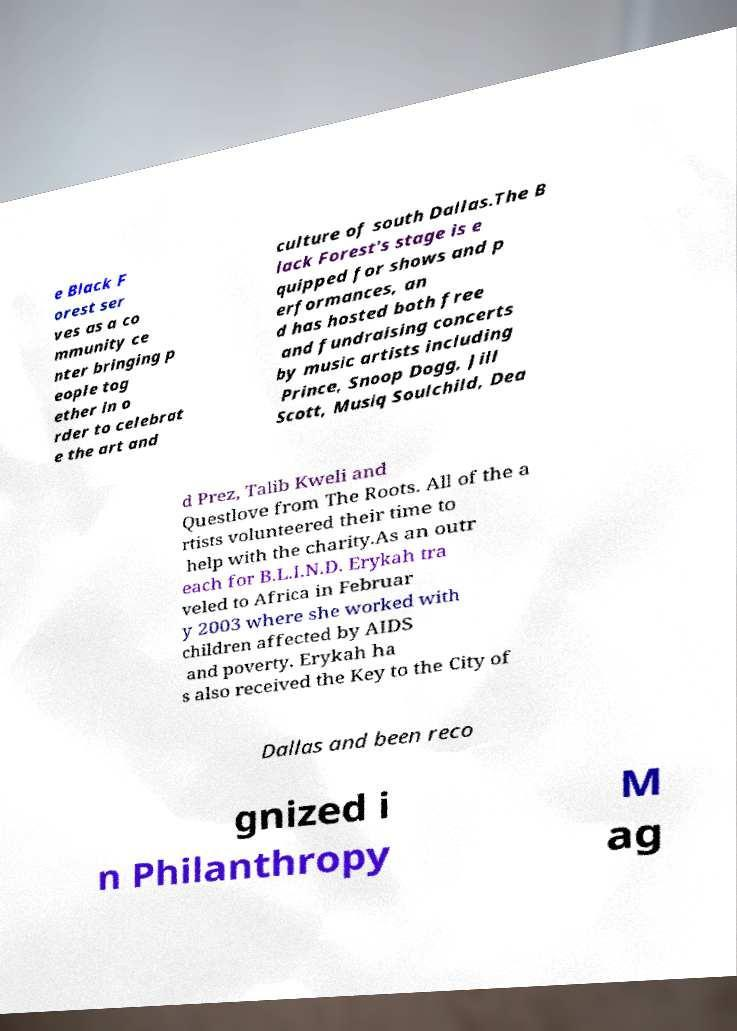I need the written content from this picture converted into text. Can you do that? e Black F orest ser ves as a co mmunity ce nter bringing p eople tog ether in o rder to celebrat e the art and culture of south Dallas.The B lack Forest's stage is e quipped for shows and p erformances, an d has hosted both free and fundraising concerts by music artists including Prince, Snoop Dogg, Jill Scott, Musiq Soulchild, Dea d Prez, Talib Kweli and Questlove from The Roots. All of the a rtists volunteered their time to help with the charity.As an outr each for B.L.I.N.D. Erykah tra veled to Africa in Februar y 2003 where she worked with children affected by AIDS and poverty. Erykah ha s also received the Key to the City of Dallas and been reco gnized i n Philanthropy M ag 